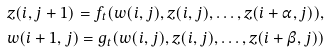<formula> <loc_0><loc_0><loc_500><loc_500>& z ( i , j + 1 ) = f _ { t } ( w ( i , j ) , z ( i , j ) , \dots , z ( i + \alpha , j ) ) , \\ & w ( i + 1 , j ) = g _ { t } ( w ( i , j ) , z ( i , j ) , \dots , z ( i + \beta , j ) )</formula> 